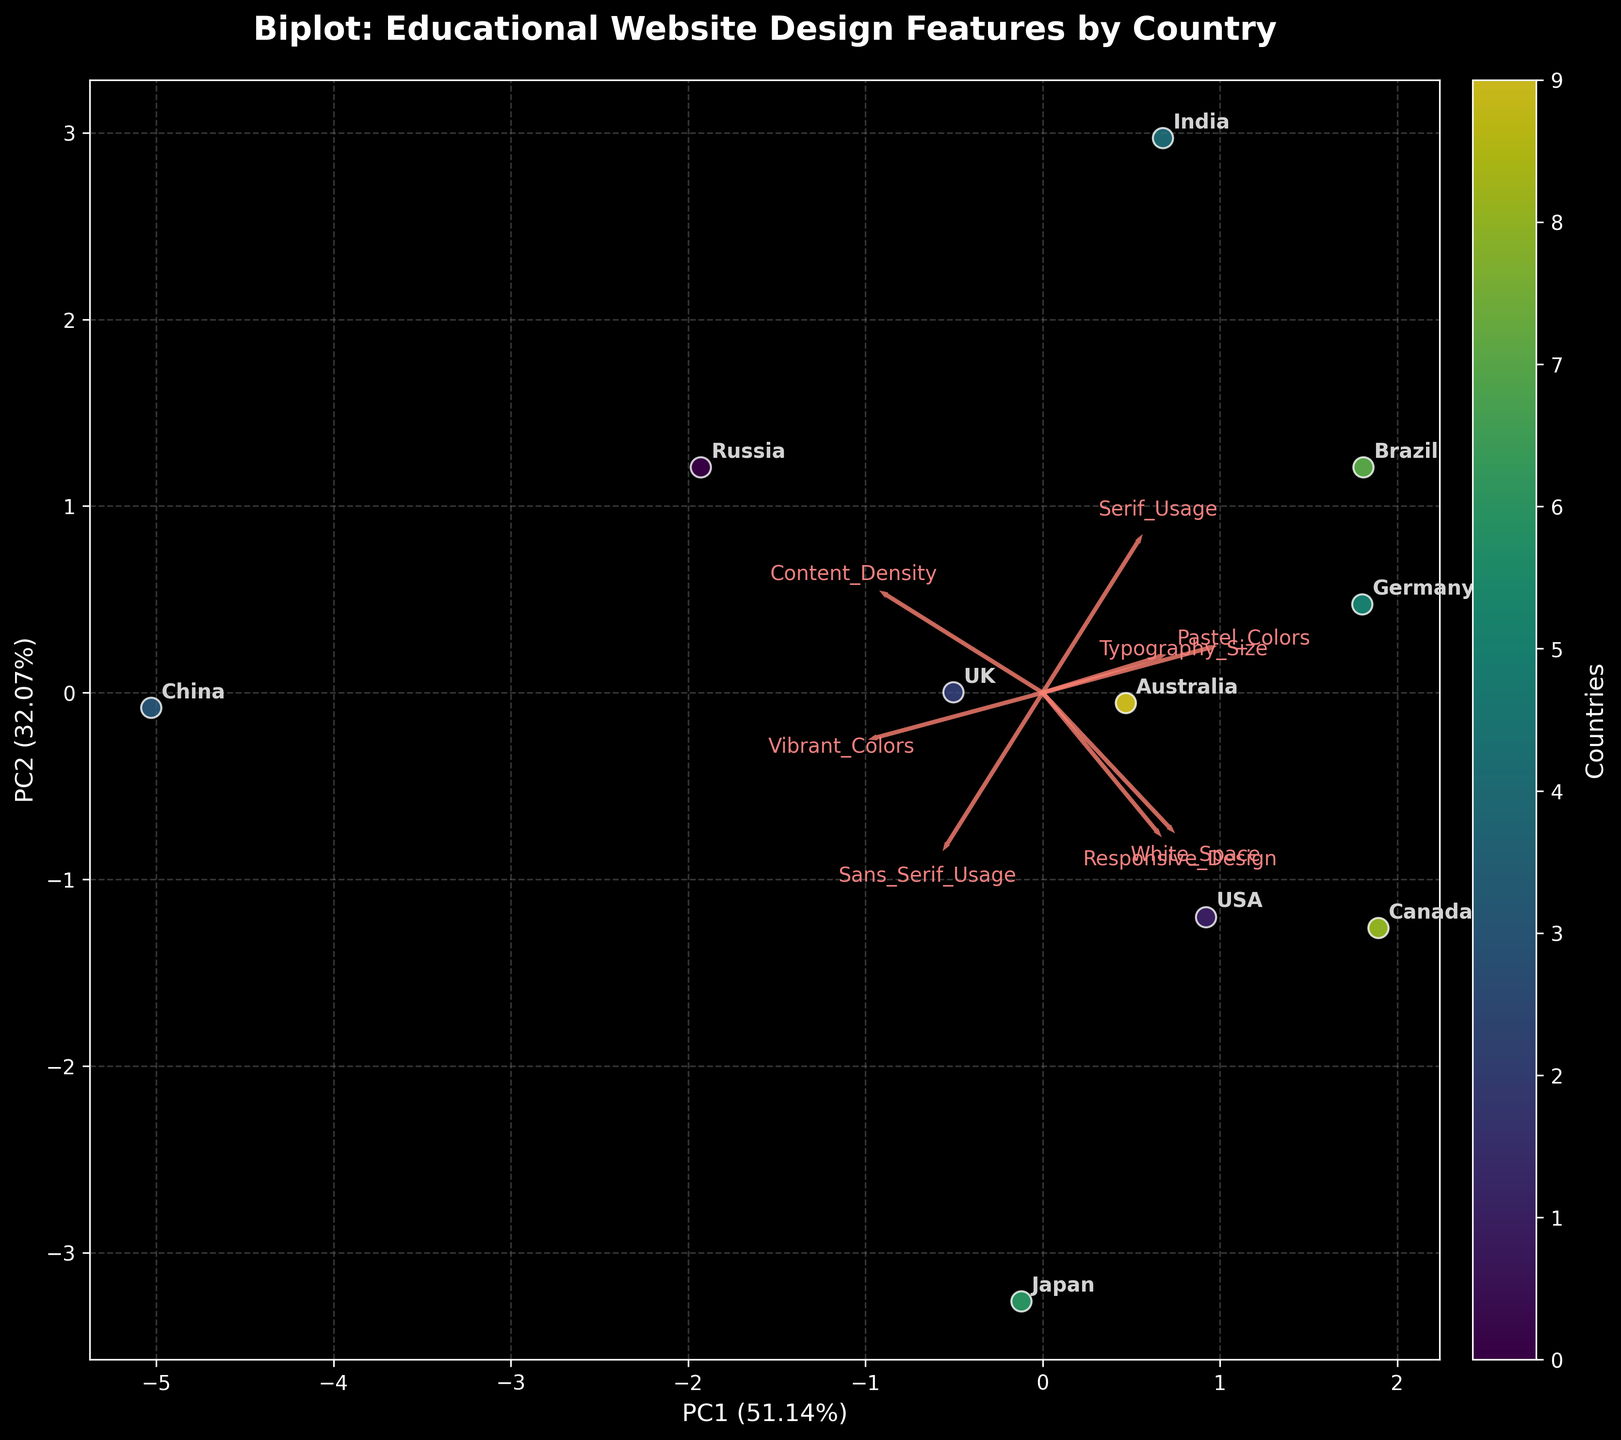What percentage of the variance is explained by PC1? Look at the x-axis label which provides the explained variance percentage for PC1.
Answer: 59.87% Which two countries have the closest design feature values according to the biplot? Find the countries with the closest positions on the biplot. The distances between data points indicate similarity in design feature values.
Answer: USA and Canada Which feature seems to contribute most to PC1? Observe the arrows (loadings) on the plot. The longest arrow aligned with the x-axis (PC1) indicates the most significant contribution to PC1.
Answer: Serif_Usage Is Brasil more aligned with pastel or vibrant colors? Identify the direction of the arrows for Pastel_Colors and Vibrant_Colors. Determine which arrow (feature) is closer to the position of Brazil on the biplot.
Answer: Pastel_Colors What general design trend for typography size can be observed among the countries? Look for the Typography_Size arrow and observe its direction. Note the relative positions of the countries along this feature's arrow.
Answer: Most countries prefer larger typography sizes Which feature shows the highest variation among countries? Identify the arrow (loading) with the largest spread across the biplot. The length and spread of arrows suggest the variance in the feature among the samples.
Answer: Responsive_Design How do India and China compare in terms of Content_Density? Look for arrows representing Content_Density and see how India and China align with this vector. Compare their projections along this arrow.
Answer: India has lower Content_Density than China Which country has the highest correlation with White_Space? Locate the White_Space arrow and identify the country closest to the tip of this arrow on the biplot. This indicates a strong positive correlation.
Answer: Japan What can be inferred about the typography choices (Serif vs. Sans_Serif) of educational websites in China? Observe China's position on the biplot relative to the Serif_Usage and Sans_Serif_Usage arrows. Determine the preference by proximity.
Answer: China prefers Sans-Serif 